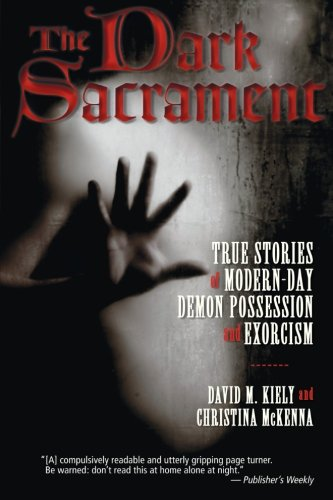What type of book is this? This is a non-fiction book focused on religion and spirituality, deeply exploring themes of demon possession and exorcism, often delving into psychological and folklore aspects. 